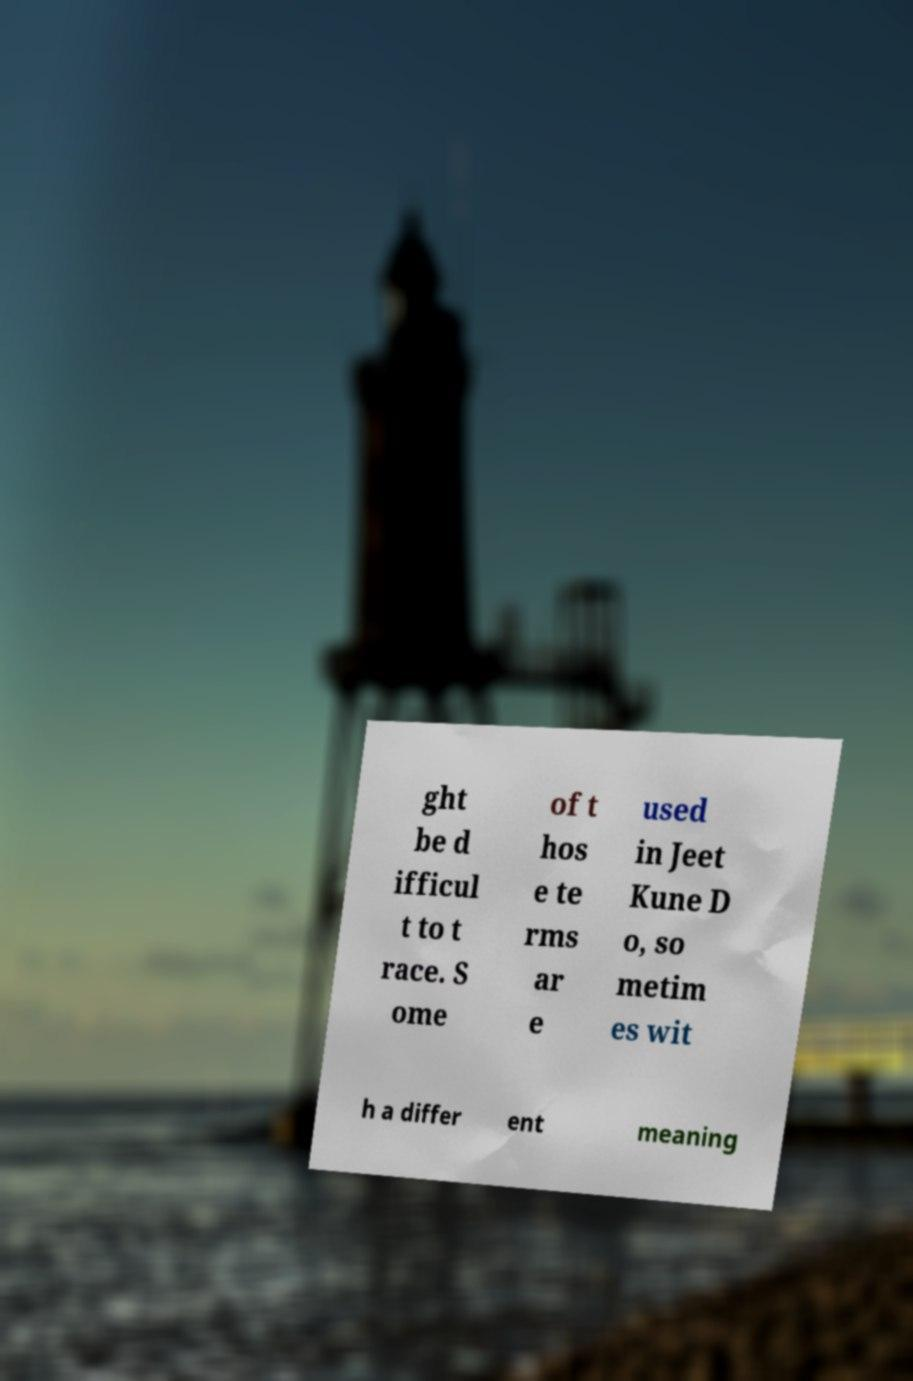What messages or text are displayed in this image? I need them in a readable, typed format. ght be d ifficul t to t race. S ome of t hos e te rms ar e used in Jeet Kune D o, so metim es wit h a differ ent meaning 